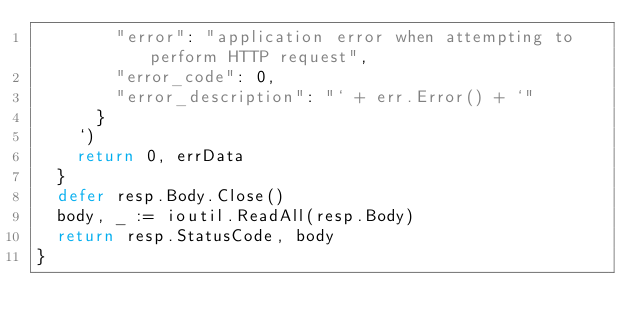<code> <loc_0><loc_0><loc_500><loc_500><_Go_>				"error": "application error when attempting to perform HTTP request",
				"error_code": 0,
				"error_description": "` + err.Error() + `"
			}
		`)
		return 0, errData
	}
	defer resp.Body.Close()
	body, _ := ioutil.ReadAll(resp.Body)
	return resp.StatusCode, body
}
</code> 